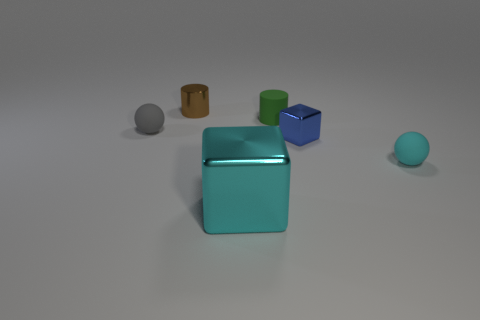What color is the tiny cube?
Make the answer very short. Blue. There is a rubber sphere on the left side of the small cyan ball; how big is it?
Offer a very short reply. Small. There is a block that is behind the small rubber ball that is right of the tiny gray object; how many tiny metal cylinders are to the right of it?
Offer a very short reply. 0. There is a tiny matte object behind the matte ball that is behind the tiny cyan matte thing; what color is it?
Offer a terse response. Green. Is there a brown matte ball that has the same size as the brown thing?
Your answer should be very brief. No. The ball that is right of the small rubber object that is behind the small sphere on the left side of the tiny brown shiny cylinder is made of what material?
Make the answer very short. Rubber. There is a tiny sphere that is behind the small cyan object; how many small objects are right of it?
Your response must be concise. 4. Does the metal block in front of the blue metallic thing have the same size as the gray object?
Your answer should be compact. No. How many other big green metallic objects have the same shape as the large metallic object?
Provide a short and direct response. 0. What shape is the small gray object?
Your answer should be compact. Sphere. 